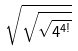<formula> <loc_0><loc_0><loc_500><loc_500>\sqrt { \sqrt { \sqrt { 4 ^ { 4 ! } } } }</formula> 